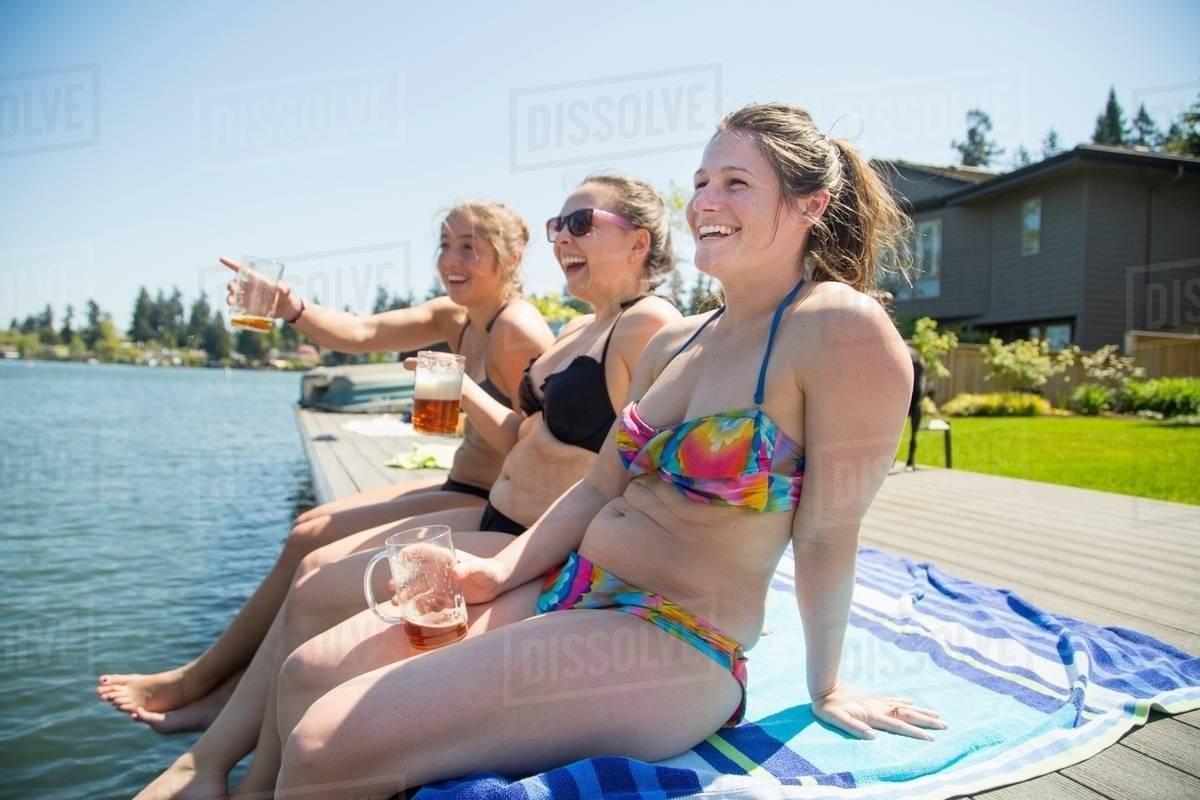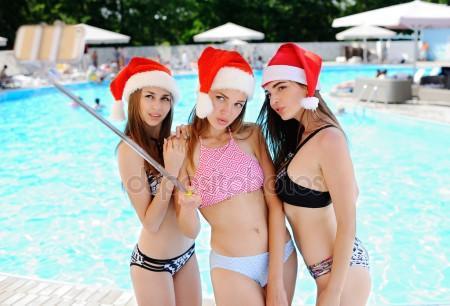The first image is the image on the left, the second image is the image on the right. Evaluate the accuracy of this statement regarding the images: "In the left image, women in bikinis are sitting on the edge of the water with their feet dangling in or above the water". Is it true? Answer yes or no. Yes. 